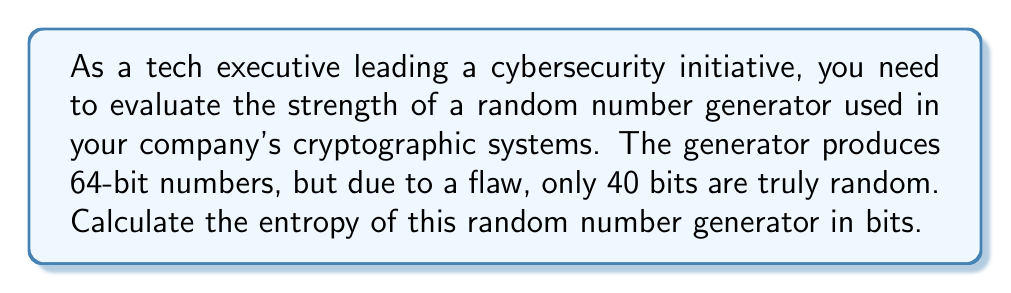Can you solve this math problem? Let's approach this step-by-step:

1) Entropy in cryptography is a measure of unpredictability or randomness. It's typically measured in bits.

2) For a truly random binary string, each bit contributes 1 bit of entropy.

3) The formula for entropy is:

   $$ H = -\sum_{i=1}^{n} p_i \log_2(p_i) $$

   Where $p_i$ is the probability of each possible outcome.

4) In our case, we have a 64-bit number generator, but only 40 bits are truly random.

5) For these 40 random bits, each possible combination has an equal probability of:

   $$ p = \frac{1}{2^{40}} $$

6) There are $2^{40}$ possible combinations for these 40 bits.

7) Plugging this into our entropy formula:

   $$ H = -\sum_{i=1}^{2^{40}} \frac{1}{2^{40}} \log_2(\frac{1}{2^{40}}) $$

8) Simplifying:

   $$ H = -2^{40} \cdot \frac{1}{2^{40}} \cdot \log_2(\frac{1}{2^{40}}) $$
   $$ H = -\log_2(\frac{1}{2^{40}}) $$
   $$ H = \log_2(2^{40}) $$
   $$ H = 40 $$

9) The remaining 24 bits (64 - 40) contribute no additional entropy as they are not truly random.

Therefore, the entropy of this random number generator is 40 bits.
Answer: 40 bits 